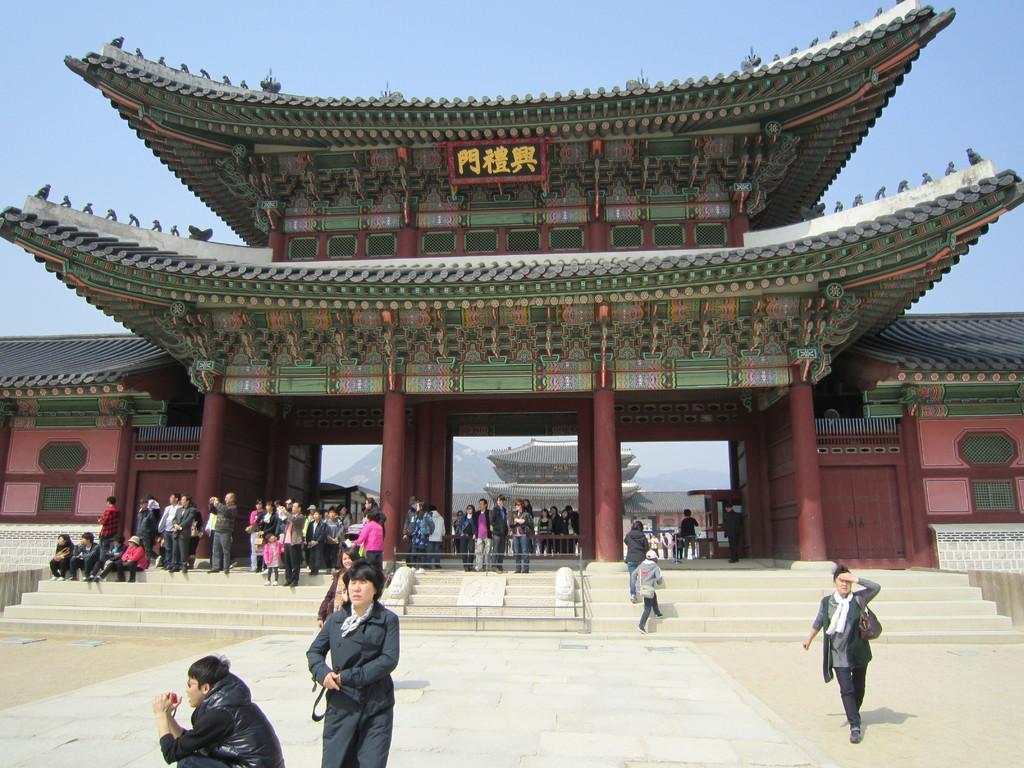Can you describe this image briefly? This picture describes about group of people, few are sitting, few are standing and few are walking, in the background we can see buildings and hills, at the top of the image we can see some text. 